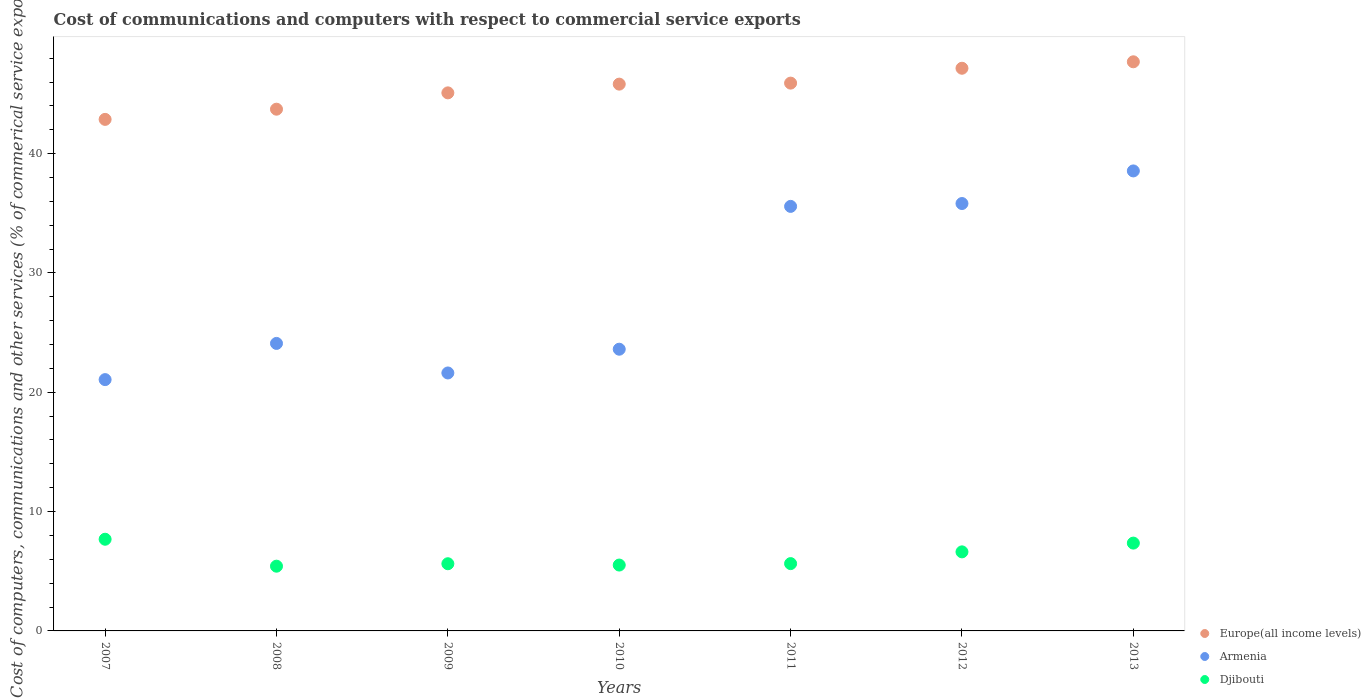What is the cost of communications and computers in Armenia in 2011?
Offer a very short reply. 35.58. Across all years, what is the maximum cost of communications and computers in Djibouti?
Your answer should be compact. 7.68. Across all years, what is the minimum cost of communications and computers in Europe(all income levels)?
Keep it short and to the point. 42.87. In which year was the cost of communications and computers in Europe(all income levels) maximum?
Your response must be concise. 2013. In which year was the cost of communications and computers in Djibouti minimum?
Give a very brief answer. 2008. What is the total cost of communications and computers in Djibouti in the graph?
Your answer should be very brief. 43.88. What is the difference between the cost of communications and computers in Europe(all income levels) in 2009 and that in 2011?
Provide a short and direct response. -0.82. What is the difference between the cost of communications and computers in Djibouti in 2011 and the cost of communications and computers in Europe(all income levels) in 2012?
Ensure brevity in your answer.  -41.51. What is the average cost of communications and computers in Djibouti per year?
Offer a terse response. 6.27. In the year 2008, what is the difference between the cost of communications and computers in Europe(all income levels) and cost of communications and computers in Armenia?
Make the answer very short. 19.63. What is the ratio of the cost of communications and computers in Armenia in 2011 to that in 2013?
Give a very brief answer. 0.92. Is the cost of communications and computers in Djibouti in 2008 less than that in 2013?
Your answer should be very brief. Yes. What is the difference between the highest and the second highest cost of communications and computers in Europe(all income levels)?
Offer a terse response. 0.54. What is the difference between the highest and the lowest cost of communications and computers in Djibouti?
Offer a very short reply. 2.26. Does the cost of communications and computers in Europe(all income levels) monotonically increase over the years?
Your response must be concise. Yes. Is the cost of communications and computers in Armenia strictly greater than the cost of communications and computers in Djibouti over the years?
Provide a short and direct response. Yes. Is the cost of communications and computers in Djibouti strictly less than the cost of communications and computers in Europe(all income levels) over the years?
Provide a short and direct response. Yes. Does the graph contain any zero values?
Ensure brevity in your answer.  No. Where does the legend appear in the graph?
Make the answer very short. Bottom right. What is the title of the graph?
Offer a terse response. Cost of communications and computers with respect to commercial service exports. What is the label or title of the X-axis?
Your response must be concise. Years. What is the label or title of the Y-axis?
Offer a terse response. Cost of computers, communications and other services (% of commerical service exports). What is the Cost of computers, communications and other services (% of commerical service exports) of Europe(all income levels) in 2007?
Your response must be concise. 42.87. What is the Cost of computers, communications and other services (% of commerical service exports) in Armenia in 2007?
Offer a very short reply. 21.06. What is the Cost of computers, communications and other services (% of commerical service exports) of Djibouti in 2007?
Your response must be concise. 7.68. What is the Cost of computers, communications and other services (% of commerical service exports) of Europe(all income levels) in 2008?
Make the answer very short. 43.72. What is the Cost of computers, communications and other services (% of commerical service exports) of Armenia in 2008?
Provide a short and direct response. 24.09. What is the Cost of computers, communications and other services (% of commerical service exports) of Djibouti in 2008?
Ensure brevity in your answer.  5.43. What is the Cost of computers, communications and other services (% of commerical service exports) of Europe(all income levels) in 2009?
Your response must be concise. 45.09. What is the Cost of computers, communications and other services (% of commerical service exports) in Armenia in 2009?
Keep it short and to the point. 21.62. What is the Cost of computers, communications and other services (% of commerical service exports) of Djibouti in 2009?
Ensure brevity in your answer.  5.63. What is the Cost of computers, communications and other services (% of commerical service exports) of Europe(all income levels) in 2010?
Your answer should be very brief. 45.82. What is the Cost of computers, communications and other services (% of commerical service exports) of Armenia in 2010?
Keep it short and to the point. 23.61. What is the Cost of computers, communications and other services (% of commerical service exports) in Djibouti in 2010?
Give a very brief answer. 5.52. What is the Cost of computers, communications and other services (% of commerical service exports) of Europe(all income levels) in 2011?
Ensure brevity in your answer.  45.91. What is the Cost of computers, communications and other services (% of commerical service exports) of Armenia in 2011?
Keep it short and to the point. 35.58. What is the Cost of computers, communications and other services (% of commerical service exports) of Djibouti in 2011?
Your answer should be compact. 5.64. What is the Cost of computers, communications and other services (% of commerical service exports) of Europe(all income levels) in 2012?
Keep it short and to the point. 47.15. What is the Cost of computers, communications and other services (% of commerical service exports) in Armenia in 2012?
Your response must be concise. 35.82. What is the Cost of computers, communications and other services (% of commerical service exports) in Djibouti in 2012?
Ensure brevity in your answer.  6.63. What is the Cost of computers, communications and other services (% of commerical service exports) in Europe(all income levels) in 2013?
Give a very brief answer. 47.69. What is the Cost of computers, communications and other services (% of commerical service exports) in Armenia in 2013?
Provide a short and direct response. 38.55. What is the Cost of computers, communications and other services (% of commerical service exports) of Djibouti in 2013?
Offer a very short reply. 7.36. Across all years, what is the maximum Cost of computers, communications and other services (% of commerical service exports) of Europe(all income levels)?
Give a very brief answer. 47.69. Across all years, what is the maximum Cost of computers, communications and other services (% of commerical service exports) in Armenia?
Ensure brevity in your answer.  38.55. Across all years, what is the maximum Cost of computers, communications and other services (% of commerical service exports) of Djibouti?
Make the answer very short. 7.68. Across all years, what is the minimum Cost of computers, communications and other services (% of commerical service exports) of Europe(all income levels)?
Offer a very short reply. 42.87. Across all years, what is the minimum Cost of computers, communications and other services (% of commerical service exports) of Armenia?
Keep it short and to the point. 21.06. Across all years, what is the minimum Cost of computers, communications and other services (% of commerical service exports) of Djibouti?
Make the answer very short. 5.43. What is the total Cost of computers, communications and other services (% of commerical service exports) of Europe(all income levels) in the graph?
Offer a very short reply. 318.25. What is the total Cost of computers, communications and other services (% of commerical service exports) in Armenia in the graph?
Offer a very short reply. 200.32. What is the total Cost of computers, communications and other services (% of commerical service exports) in Djibouti in the graph?
Provide a succinct answer. 43.88. What is the difference between the Cost of computers, communications and other services (% of commerical service exports) of Europe(all income levels) in 2007 and that in 2008?
Keep it short and to the point. -0.85. What is the difference between the Cost of computers, communications and other services (% of commerical service exports) of Armenia in 2007 and that in 2008?
Give a very brief answer. -3.03. What is the difference between the Cost of computers, communications and other services (% of commerical service exports) of Djibouti in 2007 and that in 2008?
Your response must be concise. 2.26. What is the difference between the Cost of computers, communications and other services (% of commerical service exports) in Europe(all income levels) in 2007 and that in 2009?
Provide a succinct answer. -2.22. What is the difference between the Cost of computers, communications and other services (% of commerical service exports) in Armenia in 2007 and that in 2009?
Offer a terse response. -0.56. What is the difference between the Cost of computers, communications and other services (% of commerical service exports) of Djibouti in 2007 and that in 2009?
Offer a terse response. 2.05. What is the difference between the Cost of computers, communications and other services (% of commerical service exports) of Europe(all income levels) in 2007 and that in 2010?
Your answer should be very brief. -2.95. What is the difference between the Cost of computers, communications and other services (% of commerical service exports) of Armenia in 2007 and that in 2010?
Your response must be concise. -2.55. What is the difference between the Cost of computers, communications and other services (% of commerical service exports) in Djibouti in 2007 and that in 2010?
Ensure brevity in your answer.  2.16. What is the difference between the Cost of computers, communications and other services (% of commerical service exports) of Europe(all income levels) in 2007 and that in 2011?
Ensure brevity in your answer.  -3.04. What is the difference between the Cost of computers, communications and other services (% of commerical service exports) of Armenia in 2007 and that in 2011?
Ensure brevity in your answer.  -14.52. What is the difference between the Cost of computers, communications and other services (% of commerical service exports) in Djibouti in 2007 and that in 2011?
Your answer should be compact. 2.04. What is the difference between the Cost of computers, communications and other services (% of commerical service exports) in Europe(all income levels) in 2007 and that in 2012?
Provide a short and direct response. -4.28. What is the difference between the Cost of computers, communications and other services (% of commerical service exports) in Armenia in 2007 and that in 2012?
Provide a short and direct response. -14.76. What is the difference between the Cost of computers, communications and other services (% of commerical service exports) of Djibouti in 2007 and that in 2012?
Offer a very short reply. 1.06. What is the difference between the Cost of computers, communications and other services (% of commerical service exports) in Europe(all income levels) in 2007 and that in 2013?
Keep it short and to the point. -4.83. What is the difference between the Cost of computers, communications and other services (% of commerical service exports) of Armenia in 2007 and that in 2013?
Your answer should be very brief. -17.49. What is the difference between the Cost of computers, communications and other services (% of commerical service exports) in Djibouti in 2007 and that in 2013?
Your answer should be compact. 0.32. What is the difference between the Cost of computers, communications and other services (% of commerical service exports) in Europe(all income levels) in 2008 and that in 2009?
Provide a short and direct response. -1.37. What is the difference between the Cost of computers, communications and other services (% of commerical service exports) of Armenia in 2008 and that in 2009?
Your answer should be very brief. 2.48. What is the difference between the Cost of computers, communications and other services (% of commerical service exports) of Djibouti in 2008 and that in 2009?
Give a very brief answer. -0.21. What is the difference between the Cost of computers, communications and other services (% of commerical service exports) of Europe(all income levels) in 2008 and that in 2010?
Your response must be concise. -2.1. What is the difference between the Cost of computers, communications and other services (% of commerical service exports) of Armenia in 2008 and that in 2010?
Give a very brief answer. 0.49. What is the difference between the Cost of computers, communications and other services (% of commerical service exports) in Djibouti in 2008 and that in 2010?
Your answer should be very brief. -0.09. What is the difference between the Cost of computers, communications and other services (% of commerical service exports) of Europe(all income levels) in 2008 and that in 2011?
Provide a succinct answer. -2.18. What is the difference between the Cost of computers, communications and other services (% of commerical service exports) of Armenia in 2008 and that in 2011?
Offer a very short reply. -11.48. What is the difference between the Cost of computers, communications and other services (% of commerical service exports) of Djibouti in 2008 and that in 2011?
Your answer should be compact. -0.22. What is the difference between the Cost of computers, communications and other services (% of commerical service exports) in Europe(all income levels) in 2008 and that in 2012?
Your answer should be compact. -3.43. What is the difference between the Cost of computers, communications and other services (% of commerical service exports) in Armenia in 2008 and that in 2012?
Keep it short and to the point. -11.72. What is the difference between the Cost of computers, communications and other services (% of commerical service exports) in Djibouti in 2008 and that in 2012?
Offer a terse response. -1.2. What is the difference between the Cost of computers, communications and other services (% of commerical service exports) in Europe(all income levels) in 2008 and that in 2013?
Give a very brief answer. -3.97. What is the difference between the Cost of computers, communications and other services (% of commerical service exports) in Armenia in 2008 and that in 2013?
Provide a short and direct response. -14.46. What is the difference between the Cost of computers, communications and other services (% of commerical service exports) in Djibouti in 2008 and that in 2013?
Offer a terse response. -1.93. What is the difference between the Cost of computers, communications and other services (% of commerical service exports) of Europe(all income levels) in 2009 and that in 2010?
Your answer should be compact. -0.73. What is the difference between the Cost of computers, communications and other services (% of commerical service exports) in Armenia in 2009 and that in 2010?
Your answer should be very brief. -1.99. What is the difference between the Cost of computers, communications and other services (% of commerical service exports) of Djibouti in 2009 and that in 2010?
Your answer should be very brief. 0.11. What is the difference between the Cost of computers, communications and other services (% of commerical service exports) in Europe(all income levels) in 2009 and that in 2011?
Your response must be concise. -0.82. What is the difference between the Cost of computers, communications and other services (% of commerical service exports) in Armenia in 2009 and that in 2011?
Provide a succinct answer. -13.96. What is the difference between the Cost of computers, communications and other services (% of commerical service exports) in Djibouti in 2009 and that in 2011?
Your answer should be compact. -0.01. What is the difference between the Cost of computers, communications and other services (% of commerical service exports) in Europe(all income levels) in 2009 and that in 2012?
Keep it short and to the point. -2.06. What is the difference between the Cost of computers, communications and other services (% of commerical service exports) in Armenia in 2009 and that in 2012?
Provide a short and direct response. -14.2. What is the difference between the Cost of computers, communications and other services (% of commerical service exports) in Djibouti in 2009 and that in 2012?
Provide a short and direct response. -0.99. What is the difference between the Cost of computers, communications and other services (% of commerical service exports) in Europe(all income levels) in 2009 and that in 2013?
Make the answer very short. -2.6. What is the difference between the Cost of computers, communications and other services (% of commerical service exports) of Armenia in 2009 and that in 2013?
Provide a short and direct response. -16.93. What is the difference between the Cost of computers, communications and other services (% of commerical service exports) in Djibouti in 2009 and that in 2013?
Your response must be concise. -1.73. What is the difference between the Cost of computers, communications and other services (% of commerical service exports) of Europe(all income levels) in 2010 and that in 2011?
Offer a very short reply. -0.08. What is the difference between the Cost of computers, communications and other services (% of commerical service exports) in Armenia in 2010 and that in 2011?
Make the answer very short. -11.97. What is the difference between the Cost of computers, communications and other services (% of commerical service exports) of Djibouti in 2010 and that in 2011?
Keep it short and to the point. -0.12. What is the difference between the Cost of computers, communications and other services (% of commerical service exports) in Europe(all income levels) in 2010 and that in 2012?
Offer a very short reply. -1.33. What is the difference between the Cost of computers, communications and other services (% of commerical service exports) of Armenia in 2010 and that in 2012?
Offer a terse response. -12.21. What is the difference between the Cost of computers, communications and other services (% of commerical service exports) of Djibouti in 2010 and that in 2012?
Make the answer very short. -1.11. What is the difference between the Cost of computers, communications and other services (% of commerical service exports) in Europe(all income levels) in 2010 and that in 2013?
Keep it short and to the point. -1.87. What is the difference between the Cost of computers, communications and other services (% of commerical service exports) in Armenia in 2010 and that in 2013?
Make the answer very short. -14.94. What is the difference between the Cost of computers, communications and other services (% of commerical service exports) in Djibouti in 2010 and that in 2013?
Provide a succinct answer. -1.84. What is the difference between the Cost of computers, communications and other services (% of commerical service exports) in Europe(all income levels) in 2011 and that in 2012?
Provide a succinct answer. -1.25. What is the difference between the Cost of computers, communications and other services (% of commerical service exports) of Armenia in 2011 and that in 2012?
Offer a terse response. -0.24. What is the difference between the Cost of computers, communications and other services (% of commerical service exports) in Djibouti in 2011 and that in 2012?
Your response must be concise. -0.98. What is the difference between the Cost of computers, communications and other services (% of commerical service exports) in Europe(all income levels) in 2011 and that in 2013?
Make the answer very short. -1.79. What is the difference between the Cost of computers, communications and other services (% of commerical service exports) in Armenia in 2011 and that in 2013?
Give a very brief answer. -2.97. What is the difference between the Cost of computers, communications and other services (% of commerical service exports) in Djibouti in 2011 and that in 2013?
Your answer should be very brief. -1.72. What is the difference between the Cost of computers, communications and other services (% of commerical service exports) in Europe(all income levels) in 2012 and that in 2013?
Make the answer very short. -0.54. What is the difference between the Cost of computers, communications and other services (% of commerical service exports) of Armenia in 2012 and that in 2013?
Your answer should be compact. -2.73. What is the difference between the Cost of computers, communications and other services (% of commerical service exports) of Djibouti in 2012 and that in 2013?
Your answer should be compact. -0.73. What is the difference between the Cost of computers, communications and other services (% of commerical service exports) of Europe(all income levels) in 2007 and the Cost of computers, communications and other services (% of commerical service exports) of Armenia in 2008?
Your response must be concise. 18.77. What is the difference between the Cost of computers, communications and other services (% of commerical service exports) of Europe(all income levels) in 2007 and the Cost of computers, communications and other services (% of commerical service exports) of Djibouti in 2008?
Give a very brief answer. 37.44. What is the difference between the Cost of computers, communications and other services (% of commerical service exports) of Armenia in 2007 and the Cost of computers, communications and other services (% of commerical service exports) of Djibouti in 2008?
Provide a succinct answer. 15.64. What is the difference between the Cost of computers, communications and other services (% of commerical service exports) in Europe(all income levels) in 2007 and the Cost of computers, communications and other services (% of commerical service exports) in Armenia in 2009?
Give a very brief answer. 21.25. What is the difference between the Cost of computers, communications and other services (% of commerical service exports) of Europe(all income levels) in 2007 and the Cost of computers, communications and other services (% of commerical service exports) of Djibouti in 2009?
Ensure brevity in your answer.  37.24. What is the difference between the Cost of computers, communications and other services (% of commerical service exports) of Armenia in 2007 and the Cost of computers, communications and other services (% of commerical service exports) of Djibouti in 2009?
Provide a succinct answer. 15.43. What is the difference between the Cost of computers, communications and other services (% of commerical service exports) of Europe(all income levels) in 2007 and the Cost of computers, communications and other services (% of commerical service exports) of Armenia in 2010?
Your answer should be very brief. 19.26. What is the difference between the Cost of computers, communications and other services (% of commerical service exports) of Europe(all income levels) in 2007 and the Cost of computers, communications and other services (% of commerical service exports) of Djibouti in 2010?
Offer a terse response. 37.35. What is the difference between the Cost of computers, communications and other services (% of commerical service exports) of Armenia in 2007 and the Cost of computers, communications and other services (% of commerical service exports) of Djibouti in 2010?
Your response must be concise. 15.54. What is the difference between the Cost of computers, communications and other services (% of commerical service exports) in Europe(all income levels) in 2007 and the Cost of computers, communications and other services (% of commerical service exports) in Armenia in 2011?
Provide a short and direct response. 7.29. What is the difference between the Cost of computers, communications and other services (% of commerical service exports) in Europe(all income levels) in 2007 and the Cost of computers, communications and other services (% of commerical service exports) in Djibouti in 2011?
Keep it short and to the point. 37.23. What is the difference between the Cost of computers, communications and other services (% of commerical service exports) in Armenia in 2007 and the Cost of computers, communications and other services (% of commerical service exports) in Djibouti in 2011?
Your answer should be very brief. 15.42. What is the difference between the Cost of computers, communications and other services (% of commerical service exports) of Europe(all income levels) in 2007 and the Cost of computers, communications and other services (% of commerical service exports) of Armenia in 2012?
Your answer should be compact. 7.05. What is the difference between the Cost of computers, communications and other services (% of commerical service exports) in Europe(all income levels) in 2007 and the Cost of computers, communications and other services (% of commerical service exports) in Djibouti in 2012?
Ensure brevity in your answer.  36.24. What is the difference between the Cost of computers, communications and other services (% of commerical service exports) of Armenia in 2007 and the Cost of computers, communications and other services (% of commerical service exports) of Djibouti in 2012?
Ensure brevity in your answer.  14.44. What is the difference between the Cost of computers, communications and other services (% of commerical service exports) in Europe(all income levels) in 2007 and the Cost of computers, communications and other services (% of commerical service exports) in Armenia in 2013?
Keep it short and to the point. 4.32. What is the difference between the Cost of computers, communications and other services (% of commerical service exports) in Europe(all income levels) in 2007 and the Cost of computers, communications and other services (% of commerical service exports) in Djibouti in 2013?
Offer a terse response. 35.51. What is the difference between the Cost of computers, communications and other services (% of commerical service exports) in Armenia in 2007 and the Cost of computers, communications and other services (% of commerical service exports) in Djibouti in 2013?
Your answer should be compact. 13.7. What is the difference between the Cost of computers, communications and other services (% of commerical service exports) of Europe(all income levels) in 2008 and the Cost of computers, communications and other services (% of commerical service exports) of Armenia in 2009?
Keep it short and to the point. 22.1. What is the difference between the Cost of computers, communications and other services (% of commerical service exports) in Europe(all income levels) in 2008 and the Cost of computers, communications and other services (% of commerical service exports) in Djibouti in 2009?
Ensure brevity in your answer.  38.09. What is the difference between the Cost of computers, communications and other services (% of commerical service exports) in Armenia in 2008 and the Cost of computers, communications and other services (% of commerical service exports) in Djibouti in 2009?
Offer a terse response. 18.46. What is the difference between the Cost of computers, communications and other services (% of commerical service exports) of Europe(all income levels) in 2008 and the Cost of computers, communications and other services (% of commerical service exports) of Armenia in 2010?
Offer a terse response. 20.11. What is the difference between the Cost of computers, communications and other services (% of commerical service exports) in Europe(all income levels) in 2008 and the Cost of computers, communications and other services (% of commerical service exports) in Djibouti in 2010?
Offer a very short reply. 38.2. What is the difference between the Cost of computers, communications and other services (% of commerical service exports) of Armenia in 2008 and the Cost of computers, communications and other services (% of commerical service exports) of Djibouti in 2010?
Your answer should be very brief. 18.57. What is the difference between the Cost of computers, communications and other services (% of commerical service exports) of Europe(all income levels) in 2008 and the Cost of computers, communications and other services (% of commerical service exports) of Armenia in 2011?
Your answer should be very brief. 8.15. What is the difference between the Cost of computers, communications and other services (% of commerical service exports) of Europe(all income levels) in 2008 and the Cost of computers, communications and other services (% of commerical service exports) of Djibouti in 2011?
Make the answer very short. 38.08. What is the difference between the Cost of computers, communications and other services (% of commerical service exports) of Armenia in 2008 and the Cost of computers, communications and other services (% of commerical service exports) of Djibouti in 2011?
Offer a very short reply. 18.45. What is the difference between the Cost of computers, communications and other services (% of commerical service exports) of Europe(all income levels) in 2008 and the Cost of computers, communications and other services (% of commerical service exports) of Armenia in 2012?
Offer a very short reply. 7.91. What is the difference between the Cost of computers, communications and other services (% of commerical service exports) in Europe(all income levels) in 2008 and the Cost of computers, communications and other services (% of commerical service exports) in Djibouti in 2012?
Make the answer very short. 37.1. What is the difference between the Cost of computers, communications and other services (% of commerical service exports) of Armenia in 2008 and the Cost of computers, communications and other services (% of commerical service exports) of Djibouti in 2012?
Your answer should be compact. 17.47. What is the difference between the Cost of computers, communications and other services (% of commerical service exports) in Europe(all income levels) in 2008 and the Cost of computers, communications and other services (% of commerical service exports) in Armenia in 2013?
Offer a very short reply. 5.17. What is the difference between the Cost of computers, communications and other services (% of commerical service exports) in Europe(all income levels) in 2008 and the Cost of computers, communications and other services (% of commerical service exports) in Djibouti in 2013?
Your answer should be compact. 36.36. What is the difference between the Cost of computers, communications and other services (% of commerical service exports) in Armenia in 2008 and the Cost of computers, communications and other services (% of commerical service exports) in Djibouti in 2013?
Provide a short and direct response. 16.73. What is the difference between the Cost of computers, communications and other services (% of commerical service exports) of Europe(all income levels) in 2009 and the Cost of computers, communications and other services (% of commerical service exports) of Armenia in 2010?
Provide a short and direct response. 21.48. What is the difference between the Cost of computers, communications and other services (% of commerical service exports) of Europe(all income levels) in 2009 and the Cost of computers, communications and other services (% of commerical service exports) of Djibouti in 2010?
Provide a succinct answer. 39.57. What is the difference between the Cost of computers, communications and other services (% of commerical service exports) in Armenia in 2009 and the Cost of computers, communications and other services (% of commerical service exports) in Djibouti in 2010?
Offer a very short reply. 16.1. What is the difference between the Cost of computers, communications and other services (% of commerical service exports) in Europe(all income levels) in 2009 and the Cost of computers, communications and other services (% of commerical service exports) in Armenia in 2011?
Your answer should be very brief. 9.51. What is the difference between the Cost of computers, communications and other services (% of commerical service exports) of Europe(all income levels) in 2009 and the Cost of computers, communications and other services (% of commerical service exports) of Djibouti in 2011?
Your answer should be very brief. 39.45. What is the difference between the Cost of computers, communications and other services (% of commerical service exports) of Armenia in 2009 and the Cost of computers, communications and other services (% of commerical service exports) of Djibouti in 2011?
Provide a succinct answer. 15.98. What is the difference between the Cost of computers, communications and other services (% of commerical service exports) in Europe(all income levels) in 2009 and the Cost of computers, communications and other services (% of commerical service exports) in Armenia in 2012?
Your answer should be compact. 9.27. What is the difference between the Cost of computers, communications and other services (% of commerical service exports) in Europe(all income levels) in 2009 and the Cost of computers, communications and other services (% of commerical service exports) in Djibouti in 2012?
Provide a succinct answer. 38.47. What is the difference between the Cost of computers, communications and other services (% of commerical service exports) in Armenia in 2009 and the Cost of computers, communications and other services (% of commerical service exports) in Djibouti in 2012?
Give a very brief answer. 14.99. What is the difference between the Cost of computers, communications and other services (% of commerical service exports) in Europe(all income levels) in 2009 and the Cost of computers, communications and other services (% of commerical service exports) in Armenia in 2013?
Give a very brief answer. 6.54. What is the difference between the Cost of computers, communications and other services (% of commerical service exports) of Europe(all income levels) in 2009 and the Cost of computers, communications and other services (% of commerical service exports) of Djibouti in 2013?
Provide a succinct answer. 37.73. What is the difference between the Cost of computers, communications and other services (% of commerical service exports) of Armenia in 2009 and the Cost of computers, communications and other services (% of commerical service exports) of Djibouti in 2013?
Your answer should be very brief. 14.26. What is the difference between the Cost of computers, communications and other services (% of commerical service exports) in Europe(all income levels) in 2010 and the Cost of computers, communications and other services (% of commerical service exports) in Armenia in 2011?
Give a very brief answer. 10.25. What is the difference between the Cost of computers, communications and other services (% of commerical service exports) of Europe(all income levels) in 2010 and the Cost of computers, communications and other services (% of commerical service exports) of Djibouti in 2011?
Provide a succinct answer. 40.18. What is the difference between the Cost of computers, communications and other services (% of commerical service exports) in Armenia in 2010 and the Cost of computers, communications and other services (% of commerical service exports) in Djibouti in 2011?
Give a very brief answer. 17.97. What is the difference between the Cost of computers, communications and other services (% of commerical service exports) in Europe(all income levels) in 2010 and the Cost of computers, communications and other services (% of commerical service exports) in Armenia in 2012?
Provide a short and direct response. 10.01. What is the difference between the Cost of computers, communications and other services (% of commerical service exports) in Europe(all income levels) in 2010 and the Cost of computers, communications and other services (% of commerical service exports) in Djibouti in 2012?
Offer a very short reply. 39.2. What is the difference between the Cost of computers, communications and other services (% of commerical service exports) in Armenia in 2010 and the Cost of computers, communications and other services (% of commerical service exports) in Djibouti in 2012?
Your answer should be compact. 16.98. What is the difference between the Cost of computers, communications and other services (% of commerical service exports) in Europe(all income levels) in 2010 and the Cost of computers, communications and other services (% of commerical service exports) in Armenia in 2013?
Give a very brief answer. 7.27. What is the difference between the Cost of computers, communications and other services (% of commerical service exports) in Europe(all income levels) in 2010 and the Cost of computers, communications and other services (% of commerical service exports) in Djibouti in 2013?
Provide a succinct answer. 38.46. What is the difference between the Cost of computers, communications and other services (% of commerical service exports) in Armenia in 2010 and the Cost of computers, communications and other services (% of commerical service exports) in Djibouti in 2013?
Make the answer very short. 16.25. What is the difference between the Cost of computers, communications and other services (% of commerical service exports) of Europe(all income levels) in 2011 and the Cost of computers, communications and other services (% of commerical service exports) of Armenia in 2012?
Make the answer very short. 10.09. What is the difference between the Cost of computers, communications and other services (% of commerical service exports) in Europe(all income levels) in 2011 and the Cost of computers, communications and other services (% of commerical service exports) in Djibouti in 2012?
Offer a very short reply. 39.28. What is the difference between the Cost of computers, communications and other services (% of commerical service exports) of Armenia in 2011 and the Cost of computers, communications and other services (% of commerical service exports) of Djibouti in 2012?
Your response must be concise. 28.95. What is the difference between the Cost of computers, communications and other services (% of commerical service exports) in Europe(all income levels) in 2011 and the Cost of computers, communications and other services (% of commerical service exports) in Armenia in 2013?
Make the answer very short. 7.36. What is the difference between the Cost of computers, communications and other services (% of commerical service exports) in Europe(all income levels) in 2011 and the Cost of computers, communications and other services (% of commerical service exports) in Djibouti in 2013?
Provide a short and direct response. 38.55. What is the difference between the Cost of computers, communications and other services (% of commerical service exports) in Armenia in 2011 and the Cost of computers, communications and other services (% of commerical service exports) in Djibouti in 2013?
Offer a very short reply. 28.22. What is the difference between the Cost of computers, communications and other services (% of commerical service exports) of Europe(all income levels) in 2012 and the Cost of computers, communications and other services (% of commerical service exports) of Armenia in 2013?
Your response must be concise. 8.6. What is the difference between the Cost of computers, communications and other services (% of commerical service exports) of Europe(all income levels) in 2012 and the Cost of computers, communications and other services (% of commerical service exports) of Djibouti in 2013?
Provide a succinct answer. 39.79. What is the difference between the Cost of computers, communications and other services (% of commerical service exports) of Armenia in 2012 and the Cost of computers, communications and other services (% of commerical service exports) of Djibouti in 2013?
Provide a succinct answer. 28.46. What is the average Cost of computers, communications and other services (% of commerical service exports) of Europe(all income levels) per year?
Offer a very short reply. 45.47. What is the average Cost of computers, communications and other services (% of commerical service exports) in Armenia per year?
Give a very brief answer. 28.62. What is the average Cost of computers, communications and other services (% of commerical service exports) of Djibouti per year?
Make the answer very short. 6.27. In the year 2007, what is the difference between the Cost of computers, communications and other services (% of commerical service exports) in Europe(all income levels) and Cost of computers, communications and other services (% of commerical service exports) in Armenia?
Provide a succinct answer. 21.81. In the year 2007, what is the difference between the Cost of computers, communications and other services (% of commerical service exports) in Europe(all income levels) and Cost of computers, communications and other services (% of commerical service exports) in Djibouti?
Give a very brief answer. 35.19. In the year 2007, what is the difference between the Cost of computers, communications and other services (% of commerical service exports) in Armenia and Cost of computers, communications and other services (% of commerical service exports) in Djibouti?
Your answer should be very brief. 13.38. In the year 2008, what is the difference between the Cost of computers, communications and other services (% of commerical service exports) of Europe(all income levels) and Cost of computers, communications and other services (% of commerical service exports) of Armenia?
Provide a succinct answer. 19.63. In the year 2008, what is the difference between the Cost of computers, communications and other services (% of commerical service exports) of Europe(all income levels) and Cost of computers, communications and other services (% of commerical service exports) of Djibouti?
Your response must be concise. 38.3. In the year 2008, what is the difference between the Cost of computers, communications and other services (% of commerical service exports) of Armenia and Cost of computers, communications and other services (% of commerical service exports) of Djibouti?
Offer a very short reply. 18.67. In the year 2009, what is the difference between the Cost of computers, communications and other services (% of commerical service exports) of Europe(all income levels) and Cost of computers, communications and other services (% of commerical service exports) of Armenia?
Ensure brevity in your answer.  23.47. In the year 2009, what is the difference between the Cost of computers, communications and other services (% of commerical service exports) of Europe(all income levels) and Cost of computers, communications and other services (% of commerical service exports) of Djibouti?
Provide a succinct answer. 39.46. In the year 2009, what is the difference between the Cost of computers, communications and other services (% of commerical service exports) in Armenia and Cost of computers, communications and other services (% of commerical service exports) in Djibouti?
Your response must be concise. 15.99. In the year 2010, what is the difference between the Cost of computers, communications and other services (% of commerical service exports) in Europe(all income levels) and Cost of computers, communications and other services (% of commerical service exports) in Armenia?
Make the answer very short. 22.21. In the year 2010, what is the difference between the Cost of computers, communications and other services (% of commerical service exports) of Europe(all income levels) and Cost of computers, communications and other services (% of commerical service exports) of Djibouti?
Keep it short and to the point. 40.3. In the year 2010, what is the difference between the Cost of computers, communications and other services (% of commerical service exports) of Armenia and Cost of computers, communications and other services (% of commerical service exports) of Djibouti?
Offer a very short reply. 18.09. In the year 2011, what is the difference between the Cost of computers, communications and other services (% of commerical service exports) of Europe(all income levels) and Cost of computers, communications and other services (% of commerical service exports) of Armenia?
Your answer should be very brief. 10.33. In the year 2011, what is the difference between the Cost of computers, communications and other services (% of commerical service exports) of Europe(all income levels) and Cost of computers, communications and other services (% of commerical service exports) of Djibouti?
Keep it short and to the point. 40.27. In the year 2011, what is the difference between the Cost of computers, communications and other services (% of commerical service exports) of Armenia and Cost of computers, communications and other services (% of commerical service exports) of Djibouti?
Offer a very short reply. 29.94. In the year 2012, what is the difference between the Cost of computers, communications and other services (% of commerical service exports) in Europe(all income levels) and Cost of computers, communications and other services (% of commerical service exports) in Armenia?
Offer a very short reply. 11.34. In the year 2012, what is the difference between the Cost of computers, communications and other services (% of commerical service exports) of Europe(all income levels) and Cost of computers, communications and other services (% of commerical service exports) of Djibouti?
Offer a very short reply. 40.53. In the year 2012, what is the difference between the Cost of computers, communications and other services (% of commerical service exports) in Armenia and Cost of computers, communications and other services (% of commerical service exports) in Djibouti?
Provide a short and direct response. 29.19. In the year 2013, what is the difference between the Cost of computers, communications and other services (% of commerical service exports) in Europe(all income levels) and Cost of computers, communications and other services (% of commerical service exports) in Armenia?
Your answer should be very brief. 9.15. In the year 2013, what is the difference between the Cost of computers, communications and other services (% of commerical service exports) in Europe(all income levels) and Cost of computers, communications and other services (% of commerical service exports) in Djibouti?
Give a very brief answer. 40.33. In the year 2013, what is the difference between the Cost of computers, communications and other services (% of commerical service exports) of Armenia and Cost of computers, communications and other services (% of commerical service exports) of Djibouti?
Your response must be concise. 31.19. What is the ratio of the Cost of computers, communications and other services (% of commerical service exports) in Europe(all income levels) in 2007 to that in 2008?
Your response must be concise. 0.98. What is the ratio of the Cost of computers, communications and other services (% of commerical service exports) in Armenia in 2007 to that in 2008?
Give a very brief answer. 0.87. What is the ratio of the Cost of computers, communications and other services (% of commerical service exports) in Djibouti in 2007 to that in 2008?
Provide a short and direct response. 1.42. What is the ratio of the Cost of computers, communications and other services (% of commerical service exports) of Europe(all income levels) in 2007 to that in 2009?
Give a very brief answer. 0.95. What is the ratio of the Cost of computers, communications and other services (% of commerical service exports) in Armenia in 2007 to that in 2009?
Your answer should be compact. 0.97. What is the ratio of the Cost of computers, communications and other services (% of commerical service exports) of Djibouti in 2007 to that in 2009?
Your answer should be very brief. 1.36. What is the ratio of the Cost of computers, communications and other services (% of commerical service exports) in Europe(all income levels) in 2007 to that in 2010?
Your answer should be very brief. 0.94. What is the ratio of the Cost of computers, communications and other services (% of commerical service exports) in Armenia in 2007 to that in 2010?
Offer a terse response. 0.89. What is the ratio of the Cost of computers, communications and other services (% of commerical service exports) of Djibouti in 2007 to that in 2010?
Give a very brief answer. 1.39. What is the ratio of the Cost of computers, communications and other services (% of commerical service exports) in Europe(all income levels) in 2007 to that in 2011?
Your answer should be compact. 0.93. What is the ratio of the Cost of computers, communications and other services (% of commerical service exports) in Armenia in 2007 to that in 2011?
Offer a terse response. 0.59. What is the ratio of the Cost of computers, communications and other services (% of commerical service exports) in Djibouti in 2007 to that in 2011?
Your response must be concise. 1.36. What is the ratio of the Cost of computers, communications and other services (% of commerical service exports) in Europe(all income levels) in 2007 to that in 2012?
Provide a succinct answer. 0.91. What is the ratio of the Cost of computers, communications and other services (% of commerical service exports) in Armenia in 2007 to that in 2012?
Ensure brevity in your answer.  0.59. What is the ratio of the Cost of computers, communications and other services (% of commerical service exports) in Djibouti in 2007 to that in 2012?
Offer a very short reply. 1.16. What is the ratio of the Cost of computers, communications and other services (% of commerical service exports) in Europe(all income levels) in 2007 to that in 2013?
Your response must be concise. 0.9. What is the ratio of the Cost of computers, communications and other services (% of commerical service exports) of Armenia in 2007 to that in 2013?
Give a very brief answer. 0.55. What is the ratio of the Cost of computers, communications and other services (% of commerical service exports) in Djibouti in 2007 to that in 2013?
Keep it short and to the point. 1.04. What is the ratio of the Cost of computers, communications and other services (% of commerical service exports) of Europe(all income levels) in 2008 to that in 2009?
Provide a short and direct response. 0.97. What is the ratio of the Cost of computers, communications and other services (% of commerical service exports) of Armenia in 2008 to that in 2009?
Provide a succinct answer. 1.11. What is the ratio of the Cost of computers, communications and other services (% of commerical service exports) in Djibouti in 2008 to that in 2009?
Make the answer very short. 0.96. What is the ratio of the Cost of computers, communications and other services (% of commerical service exports) in Europe(all income levels) in 2008 to that in 2010?
Keep it short and to the point. 0.95. What is the ratio of the Cost of computers, communications and other services (% of commerical service exports) of Armenia in 2008 to that in 2010?
Provide a succinct answer. 1.02. What is the ratio of the Cost of computers, communications and other services (% of commerical service exports) of Djibouti in 2008 to that in 2010?
Give a very brief answer. 0.98. What is the ratio of the Cost of computers, communications and other services (% of commerical service exports) of Armenia in 2008 to that in 2011?
Ensure brevity in your answer.  0.68. What is the ratio of the Cost of computers, communications and other services (% of commerical service exports) in Djibouti in 2008 to that in 2011?
Your answer should be very brief. 0.96. What is the ratio of the Cost of computers, communications and other services (% of commerical service exports) in Europe(all income levels) in 2008 to that in 2012?
Provide a succinct answer. 0.93. What is the ratio of the Cost of computers, communications and other services (% of commerical service exports) of Armenia in 2008 to that in 2012?
Provide a short and direct response. 0.67. What is the ratio of the Cost of computers, communications and other services (% of commerical service exports) of Djibouti in 2008 to that in 2012?
Provide a short and direct response. 0.82. What is the ratio of the Cost of computers, communications and other services (% of commerical service exports) in Djibouti in 2008 to that in 2013?
Provide a succinct answer. 0.74. What is the ratio of the Cost of computers, communications and other services (% of commerical service exports) in Armenia in 2009 to that in 2010?
Offer a terse response. 0.92. What is the ratio of the Cost of computers, communications and other services (% of commerical service exports) in Djibouti in 2009 to that in 2010?
Provide a short and direct response. 1.02. What is the ratio of the Cost of computers, communications and other services (% of commerical service exports) of Europe(all income levels) in 2009 to that in 2011?
Your answer should be very brief. 0.98. What is the ratio of the Cost of computers, communications and other services (% of commerical service exports) of Armenia in 2009 to that in 2011?
Your answer should be very brief. 0.61. What is the ratio of the Cost of computers, communications and other services (% of commerical service exports) in Europe(all income levels) in 2009 to that in 2012?
Your answer should be very brief. 0.96. What is the ratio of the Cost of computers, communications and other services (% of commerical service exports) of Armenia in 2009 to that in 2012?
Your response must be concise. 0.6. What is the ratio of the Cost of computers, communications and other services (% of commerical service exports) in Djibouti in 2009 to that in 2012?
Make the answer very short. 0.85. What is the ratio of the Cost of computers, communications and other services (% of commerical service exports) in Europe(all income levels) in 2009 to that in 2013?
Ensure brevity in your answer.  0.95. What is the ratio of the Cost of computers, communications and other services (% of commerical service exports) in Armenia in 2009 to that in 2013?
Provide a short and direct response. 0.56. What is the ratio of the Cost of computers, communications and other services (% of commerical service exports) of Djibouti in 2009 to that in 2013?
Ensure brevity in your answer.  0.77. What is the ratio of the Cost of computers, communications and other services (% of commerical service exports) of Europe(all income levels) in 2010 to that in 2011?
Keep it short and to the point. 1. What is the ratio of the Cost of computers, communications and other services (% of commerical service exports) in Armenia in 2010 to that in 2011?
Your answer should be very brief. 0.66. What is the ratio of the Cost of computers, communications and other services (% of commerical service exports) of Djibouti in 2010 to that in 2011?
Your response must be concise. 0.98. What is the ratio of the Cost of computers, communications and other services (% of commerical service exports) of Europe(all income levels) in 2010 to that in 2012?
Offer a very short reply. 0.97. What is the ratio of the Cost of computers, communications and other services (% of commerical service exports) in Armenia in 2010 to that in 2012?
Offer a very short reply. 0.66. What is the ratio of the Cost of computers, communications and other services (% of commerical service exports) in Djibouti in 2010 to that in 2012?
Ensure brevity in your answer.  0.83. What is the ratio of the Cost of computers, communications and other services (% of commerical service exports) in Europe(all income levels) in 2010 to that in 2013?
Give a very brief answer. 0.96. What is the ratio of the Cost of computers, communications and other services (% of commerical service exports) of Armenia in 2010 to that in 2013?
Provide a succinct answer. 0.61. What is the ratio of the Cost of computers, communications and other services (% of commerical service exports) in Djibouti in 2010 to that in 2013?
Keep it short and to the point. 0.75. What is the ratio of the Cost of computers, communications and other services (% of commerical service exports) of Europe(all income levels) in 2011 to that in 2012?
Your answer should be compact. 0.97. What is the ratio of the Cost of computers, communications and other services (% of commerical service exports) in Armenia in 2011 to that in 2012?
Provide a short and direct response. 0.99. What is the ratio of the Cost of computers, communications and other services (% of commerical service exports) in Djibouti in 2011 to that in 2012?
Provide a short and direct response. 0.85. What is the ratio of the Cost of computers, communications and other services (% of commerical service exports) of Europe(all income levels) in 2011 to that in 2013?
Keep it short and to the point. 0.96. What is the ratio of the Cost of computers, communications and other services (% of commerical service exports) of Armenia in 2011 to that in 2013?
Offer a terse response. 0.92. What is the ratio of the Cost of computers, communications and other services (% of commerical service exports) of Djibouti in 2011 to that in 2013?
Your answer should be very brief. 0.77. What is the ratio of the Cost of computers, communications and other services (% of commerical service exports) of Europe(all income levels) in 2012 to that in 2013?
Offer a terse response. 0.99. What is the ratio of the Cost of computers, communications and other services (% of commerical service exports) of Armenia in 2012 to that in 2013?
Offer a terse response. 0.93. What is the ratio of the Cost of computers, communications and other services (% of commerical service exports) in Djibouti in 2012 to that in 2013?
Your response must be concise. 0.9. What is the difference between the highest and the second highest Cost of computers, communications and other services (% of commerical service exports) in Europe(all income levels)?
Provide a short and direct response. 0.54. What is the difference between the highest and the second highest Cost of computers, communications and other services (% of commerical service exports) in Armenia?
Offer a terse response. 2.73. What is the difference between the highest and the second highest Cost of computers, communications and other services (% of commerical service exports) in Djibouti?
Ensure brevity in your answer.  0.32. What is the difference between the highest and the lowest Cost of computers, communications and other services (% of commerical service exports) of Europe(all income levels)?
Provide a succinct answer. 4.83. What is the difference between the highest and the lowest Cost of computers, communications and other services (% of commerical service exports) of Armenia?
Make the answer very short. 17.49. What is the difference between the highest and the lowest Cost of computers, communications and other services (% of commerical service exports) of Djibouti?
Your answer should be very brief. 2.26. 